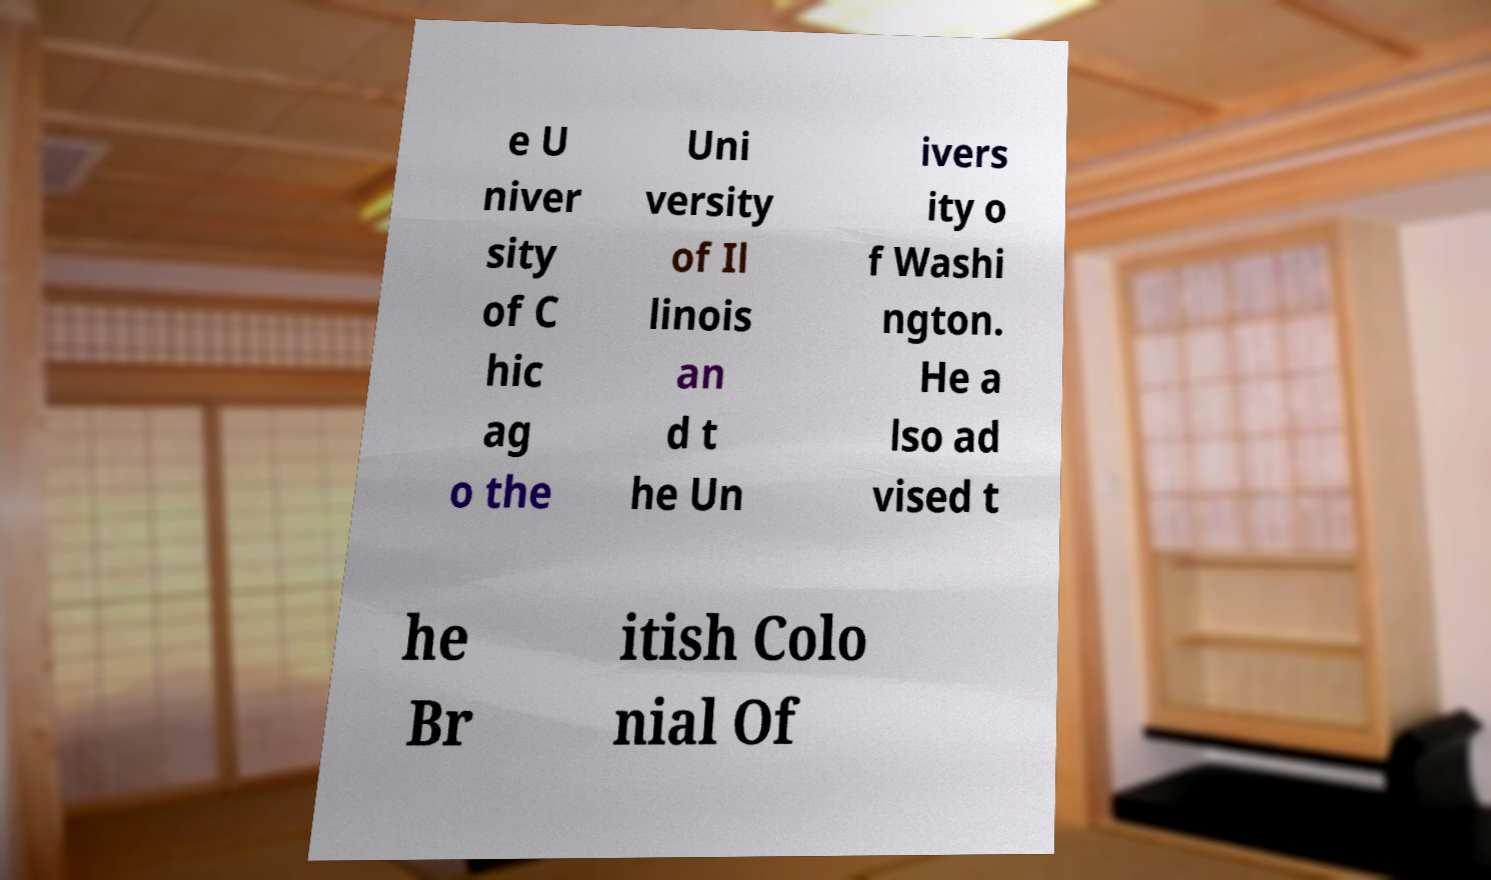Could you extract and type out the text from this image? e U niver sity of C hic ag o the Uni versity of Il linois an d t he Un ivers ity o f Washi ngton. He a lso ad vised t he Br itish Colo nial Of 